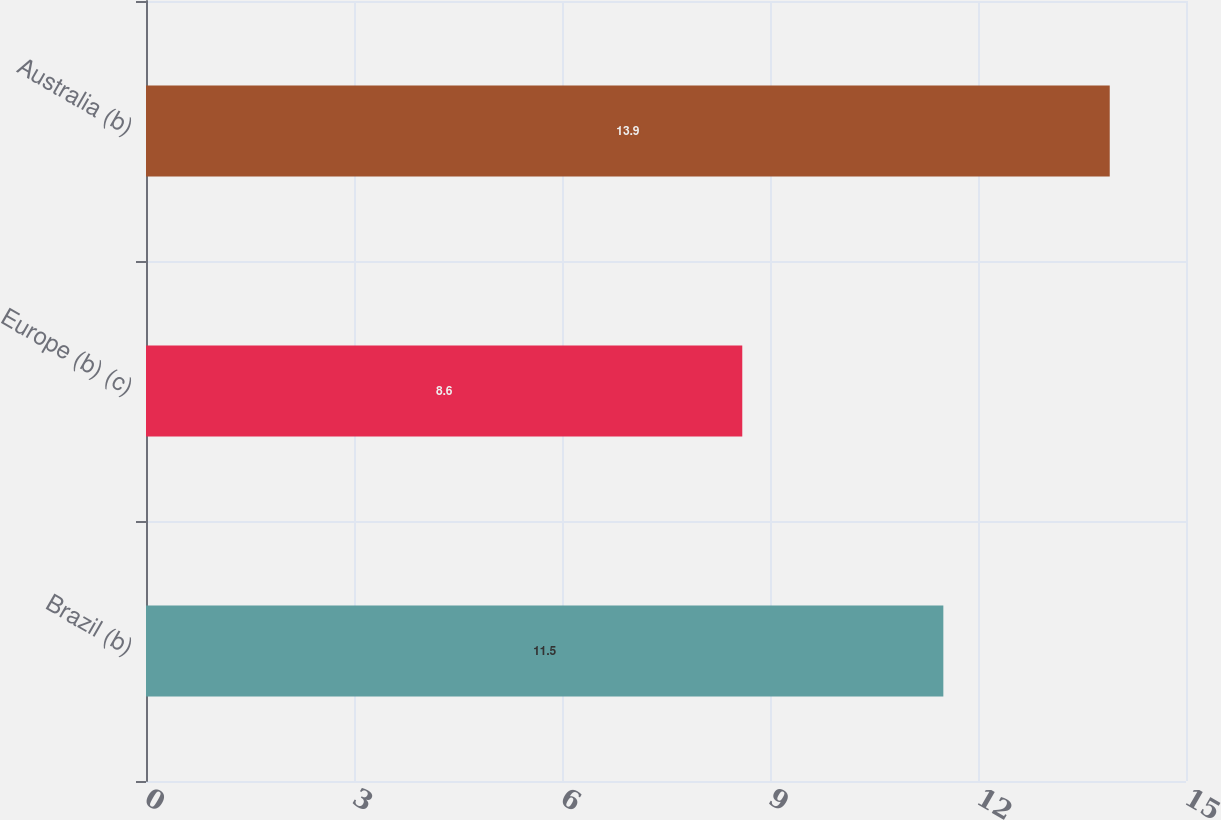Convert chart to OTSL. <chart><loc_0><loc_0><loc_500><loc_500><bar_chart><fcel>Brazil (b)<fcel>Europe (b) (c)<fcel>Australia (b)<nl><fcel>11.5<fcel>8.6<fcel>13.9<nl></chart> 